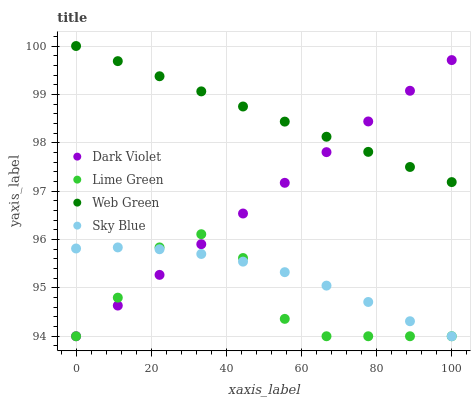Does Lime Green have the minimum area under the curve?
Answer yes or no. Yes. Does Web Green have the maximum area under the curve?
Answer yes or no. Yes. Does Web Green have the minimum area under the curve?
Answer yes or no. No. Does Lime Green have the maximum area under the curve?
Answer yes or no. No. Is Dark Violet the smoothest?
Answer yes or no. Yes. Is Lime Green the roughest?
Answer yes or no. Yes. Is Web Green the smoothest?
Answer yes or no. No. Is Web Green the roughest?
Answer yes or no. No. Does Sky Blue have the lowest value?
Answer yes or no. Yes. Does Web Green have the lowest value?
Answer yes or no. No. Does Web Green have the highest value?
Answer yes or no. Yes. Does Lime Green have the highest value?
Answer yes or no. No. Is Sky Blue less than Web Green?
Answer yes or no. Yes. Is Web Green greater than Sky Blue?
Answer yes or no. Yes. Does Lime Green intersect Sky Blue?
Answer yes or no. Yes. Is Lime Green less than Sky Blue?
Answer yes or no. No. Is Lime Green greater than Sky Blue?
Answer yes or no. No. Does Sky Blue intersect Web Green?
Answer yes or no. No. 